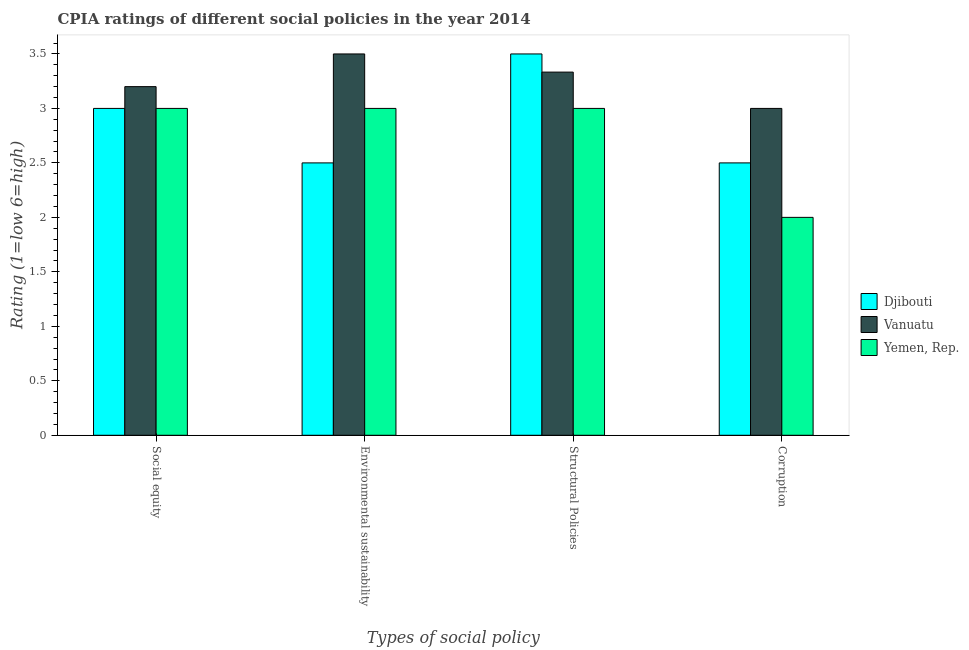How many different coloured bars are there?
Make the answer very short. 3. How many groups of bars are there?
Give a very brief answer. 4. Are the number of bars per tick equal to the number of legend labels?
Provide a short and direct response. Yes. How many bars are there on the 1st tick from the left?
Keep it short and to the point. 3. How many bars are there on the 2nd tick from the right?
Provide a short and direct response. 3. What is the label of the 3rd group of bars from the left?
Give a very brief answer. Structural Policies. What is the cpia rating of structural policies in Vanuatu?
Ensure brevity in your answer.  3.33. Across all countries, what is the minimum cpia rating of corruption?
Offer a terse response. 2. In which country was the cpia rating of environmental sustainability maximum?
Your response must be concise. Vanuatu. In which country was the cpia rating of structural policies minimum?
Your answer should be very brief. Yemen, Rep. What is the total cpia rating of environmental sustainability in the graph?
Your answer should be compact. 9. What is the difference between the cpia rating of social equity in Djibouti and that in Vanuatu?
Your answer should be compact. -0.2. What is the average cpia rating of corruption per country?
Offer a very short reply. 2.5. What is the difference between the cpia rating of structural policies and cpia rating of social equity in Vanuatu?
Make the answer very short. 0.13. In how many countries, is the cpia rating of structural policies greater than 2.8 ?
Your answer should be compact. 3. What is the ratio of the cpia rating of social equity in Djibouti to that in Yemen, Rep.?
Offer a very short reply. 1. What is the difference between the highest and the second highest cpia rating of environmental sustainability?
Offer a very short reply. 0.5. What is the difference between the highest and the lowest cpia rating of social equity?
Your answer should be compact. 0.2. Is it the case that in every country, the sum of the cpia rating of corruption and cpia rating of environmental sustainability is greater than the sum of cpia rating of social equity and cpia rating of structural policies?
Your response must be concise. No. What does the 2nd bar from the left in Structural Policies represents?
Give a very brief answer. Vanuatu. What does the 1st bar from the right in Corruption represents?
Offer a terse response. Yemen, Rep. Is it the case that in every country, the sum of the cpia rating of social equity and cpia rating of environmental sustainability is greater than the cpia rating of structural policies?
Give a very brief answer. Yes. Are all the bars in the graph horizontal?
Ensure brevity in your answer.  No. What is the difference between two consecutive major ticks on the Y-axis?
Offer a terse response. 0.5. Does the graph contain any zero values?
Your answer should be compact. No. How many legend labels are there?
Your answer should be compact. 3. What is the title of the graph?
Give a very brief answer. CPIA ratings of different social policies in the year 2014. What is the label or title of the X-axis?
Your answer should be very brief. Types of social policy. What is the Rating (1=low 6=high) in Djibouti in Environmental sustainability?
Your answer should be compact. 2.5. What is the Rating (1=low 6=high) in Vanuatu in Environmental sustainability?
Offer a very short reply. 3.5. What is the Rating (1=low 6=high) in Yemen, Rep. in Environmental sustainability?
Offer a very short reply. 3. What is the Rating (1=low 6=high) of Vanuatu in Structural Policies?
Keep it short and to the point. 3.33. What is the Rating (1=low 6=high) of Yemen, Rep. in Structural Policies?
Make the answer very short. 3. What is the Rating (1=low 6=high) of Vanuatu in Corruption?
Provide a short and direct response. 3. Across all Types of social policy, what is the maximum Rating (1=low 6=high) in Djibouti?
Keep it short and to the point. 3.5. Across all Types of social policy, what is the maximum Rating (1=low 6=high) of Vanuatu?
Keep it short and to the point. 3.5. Across all Types of social policy, what is the minimum Rating (1=low 6=high) in Vanuatu?
Keep it short and to the point. 3. Across all Types of social policy, what is the minimum Rating (1=low 6=high) of Yemen, Rep.?
Make the answer very short. 2. What is the total Rating (1=low 6=high) of Djibouti in the graph?
Provide a succinct answer. 11.5. What is the total Rating (1=low 6=high) in Vanuatu in the graph?
Ensure brevity in your answer.  13.03. What is the total Rating (1=low 6=high) in Yemen, Rep. in the graph?
Give a very brief answer. 11. What is the difference between the Rating (1=low 6=high) of Djibouti in Social equity and that in Environmental sustainability?
Make the answer very short. 0.5. What is the difference between the Rating (1=low 6=high) in Yemen, Rep. in Social equity and that in Environmental sustainability?
Your answer should be compact. 0. What is the difference between the Rating (1=low 6=high) in Djibouti in Social equity and that in Structural Policies?
Your response must be concise. -0.5. What is the difference between the Rating (1=low 6=high) in Vanuatu in Social equity and that in Structural Policies?
Offer a terse response. -0.13. What is the difference between the Rating (1=low 6=high) in Yemen, Rep. in Social equity and that in Structural Policies?
Ensure brevity in your answer.  0. What is the difference between the Rating (1=low 6=high) in Djibouti in Social equity and that in Corruption?
Your response must be concise. 0.5. What is the difference between the Rating (1=low 6=high) of Vanuatu in Environmental sustainability and that in Structural Policies?
Ensure brevity in your answer.  0.17. What is the difference between the Rating (1=low 6=high) of Djibouti in Environmental sustainability and that in Corruption?
Provide a short and direct response. 0. What is the difference between the Rating (1=low 6=high) of Djibouti in Structural Policies and that in Corruption?
Offer a very short reply. 1. What is the difference between the Rating (1=low 6=high) of Vanuatu in Social equity and the Rating (1=low 6=high) of Yemen, Rep. in Environmental sustainability?
Your answer should be very brief. 0.2. What is the difference between the Rating (1=low 6=high) in Djibouti in Social equity and the Rating (1=low 6=high) in Vanuatu in Corruption?
Offer a very short reply. 0. What is the difference between the Rating (1=low 6=high) of Djibouti in Social equity and the Rating (1=low 6=high) of Yemen, Rep. in Corruption?
Provide a short and direct response. 1. What is the difference between the Rating (1=low 6=high) of Djibouti in Environmental sustainability and the Rating (1=low 6=high) of Yemen, Rep. in Structural Policies?
Keep it short and to the point. -0.5. What is the difference between the Rating (1=low 6=high) in Vanuatu in Environmental sustainability and the Rating (1=low 6=high) in Yemen, Rep. in Corruption?
Your response must be concise. 1.5. What is the difference between the Rating (1=low 6=high) of Djibouti in Structural Policies and the Rating (1=low 6=high) of Vanuatu in Corruption?
Offer a terse response. 0.5. What is the difference between the Rating (1=low 6=high) of Djibouti in Structural Policies and the Rating (1=low 6=high) of Yemen, Rep. in Corruption?
Ensure brevity in your answer.  1.5. What is the difference between the Rating (1=low 6=high) in Vanuatu in Structural Policies and the Rating (1=low 6=high) in Yemen, Rep. in Corruption?
Give a very brief answer. 1.33. What is the average Rating (1=low 6=high) of Djibouti per Types of social policy?
Offer a very short reply. 2.88. What is the average Rating (1=low 6=high) in Vanuatu per Types of social policy?
Offer a terse response. 3.26. What is the average Rating (1=low 6=high) in Yemen, Rep. per Types of social policy?
Your answer should be very brief. 2.75. What is the difference between the Rating (1=low 6=high) in Djibouti and Rating (1=low 6=high) in Yemen, Rep. in Social equity?
Your answer should be very brief. 0. What is the difference between the Rating (1=low 6=high) in Vanuatu and Rating (1=low 6=high) in Yemen, Rep. in Social equity?
Provide a succinct answer. 0.2. What is the difference between the Rating (1=low 6=high) in Djibouti and Rating (1=low 6=high) in Vanuatu in Structural Policies?
Ensure brevity in your answer.  0.17. What is the difference between the Rating (1=low 6=high) of Djibouti and Rating (1=low 6=high) of Yemen, Rep. in Structural Policies?
Your answer should be compact. 0.5. What is the difference between the Rating (1=low 6=high) of Djibouti and Rating (1=low 6=high) of Vanuatu in Corruption?
Your response must be concise. -0.5. What is the difference between the Rating (1=low 6=high) of Djibouti and Rating (1=low 6=high) of Yemen, Rep. in Corruption?
Your answer should be very brief. 0.5. What is the ratio of the Rating (1=low 6=high) in Vanuatu in Social equity to that in Environmental sustainability?
Give a very brief answer. 0.91. What is the ratio of the Rating (1=low 6=high) in Djibouti in Social equity to that in Structural Policies?
Offer a very short reply. 0.86. What is the ratio of the Rating (1=low 6=high) in Vanuatu in Social equity to that in Corruption?
Offer a very short reply. 1.07. What is the ratio of the Rating (1=low 6=high) in Yemen, Rep. in Environmental sustainability to that in Structural Policies?
Provide a succinct answer. 1. What is the ratio of the Rating (1=low 6=high) of Yemen, Rep. in Environmental sustainability to that in Corruption?
Provide a succinct answer. 1.5. What is the ratio of the Rating (1=low 6=high) in Djibouti in Structural Policies to that in Corruption?
Your answer should be compact. 1.4. What is the ratio of the Rating (1=low 6=high) of Vanuatu in Structural Policies to that in Corruption?
Offer a terse response. 1.11. What is the difference between the highest and the second highest Rating (1=low 6=high) in Yemen, Rep.?
Provide a succinct answer. 0. What is the difference between the highest and the lowest Rating (1=low 6=high) in Vanuatu?
Your response must be concise. 0.5. What is the difference between the highest and the lowest Rating (1=low 6=high) in Yemen, Rep.?
Offer a very short reply. 1. 